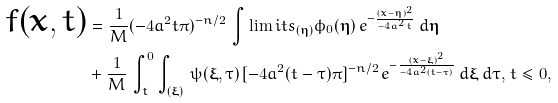Convert formula to latex. <formula><loc_0><loc_0><loc_500><loc_500>f ( { \boldsymbol x } , t ) & = \frac { 1 } { M } ( - 4 a ^ { 2 } t \pi ) ^ { - n / 2 } \, \int \lim i t s _ { ( \boldsymbol \eta ) } \phi _ { 0 } ( { \boldsymbol \eta } ) \, e ^ { - \frac { ( \boldsymbol x - \boldsymbol \eta ) ^ { 2 } } { - 4 a ^ { 2 } t } } \, d { \boldsymbol \eta } \\ \, & + \frac { 1 } { M } \, \int ^ { 0 } _ { t } \int _ { ( { \boldsymbol \xi } ) } \, \psi ( { \boldsymbol \xi } , \tau ) \, [ - 4 a ^ { 2 } ( t - \tau ) \pi ] ^ { - n / 2 } \, e ^ { - \frac { ( \boldsymbol x - \boldsymbol \xi ) ^ { 2 } } { - 4 a ^ { 2 } ( t - \tau ) } } \, d { \boldsymbol \xi } \, d \tau , \, t \leq 0 ,</formula> 